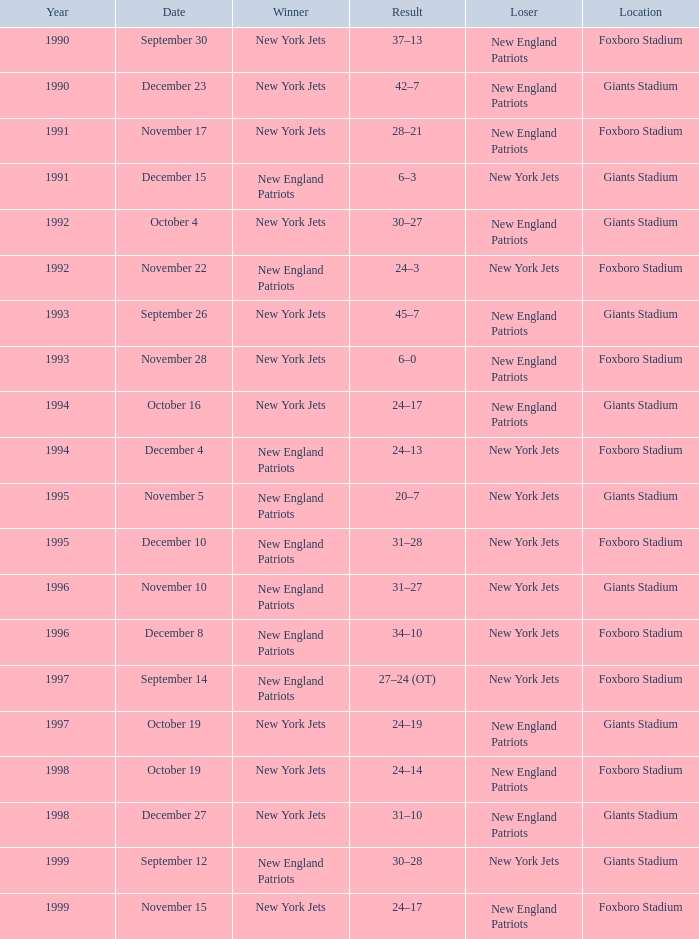What team was the lesser when the winning team was the new york jets, and a year before 1994, with a 37-13 outcome? New England Patriots. Parse the full table. {'header': ['Year', 'Date', 'Winner', 'Result', 'Loser', 'Location'], 'rows': [['1990', 'September 30', 'New York Jets', '37–13', 'New England Patriots', 'Foxboro Stadium'], ['1990', 'December 23', 'New York Jets', '42–7', 'New England Patriots', 'Giants Stadium'], ['1991', 'November 17', 'New York Jets', '28–21', 'New England Patriots', 'Foxboro Stadium'], ['1991', 'December 15', 'New England Patriots', '6–3', 'New York Jets', 'Giants Stadium'], ['1992', 'October 4', 'New York Jets', '30–27', 'New England Patriots', 'Giants Stadium'], ['1992', 'November 22', 'New England Patriots', '24–3', 'New York Jets', 'Foxboro Stadium'], ['1993', 'September 26', 'New York Jets', '45–7', 'New England Patriots', 'Giants Stadium'], ['1993', 'November 28', 'New York Jets', '6–0', 'New England Patriots', 'Foxboro Stadium'], ['1994', 'October 16', 'New York Jets', '24–17', 'New England Patriots', 'Giants Stadium'], ['1994', 'December 4', 'New England Patriots', '24–13', 'New York Jets', 'Foxboro Stadium'], ['1995', 'November 5', 'New England Patriots', '20–7', 'New York Jets', 'Giants Stadium'], ['1995', 'December 10', 'New England Patriots', '31–28', 'New York Jets', 'Foxboro Stadium'], ['1996', 'November 10', 'New England Patriots', '31–27', 'New York Jets', 'Giants Stadium'], ['1996', 'December 8', 'New England Patriots', '34–10', 'New York Jets', 'Foxboro Stadium'], ['1997', 'September 14', 'New England Patriots', '27–24 (OT)', 'New York Jets', 'Foxboro Stadium'], ['1997', 'October 19', 'New York Jets', '24–19', 'New England Patriots', 'Giants Stadium'], ['1998', 'October 19', 'New York Jets', '24–14', 'New England Patriots', 'Foxboro Stadium'], ['1998', 'December 27', 'New York Jets', '31–10', 'New England Patriots', 'Giants Stadium'], ['1999', 'September 12', 'New England Patriots', '30–28', 'New York Jets', 'Giants Stadium'], ['1999', 'November 15', 'New York Jets', '24–17', 'New England Patriots', 'Foxboro Stadium']]} 